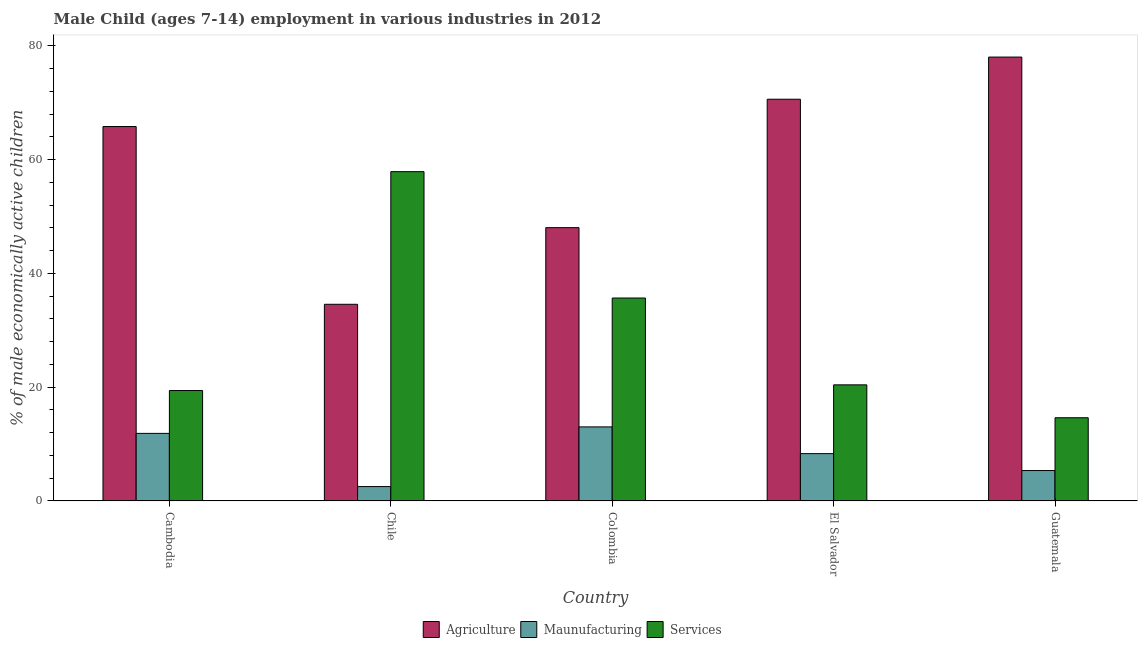How many different coloured bars are there?
Keep it short and to the point. 3. How many groups of bars are there?
Your answer should be very brief. 5. Are the number of bars per tick equal to the number of legend labels?
Ensure brevity in your answer.  Yes. Are the number of bars on each tick of the X-axis equal?
Provide a short and direct response. Yes. How many bars are there on the 5th tick from the right?
Make the answer very short. 3. What is the percentage of economically active children in agriculture in Colombia?
Offer a very short reply. 48.04. Across all countries, what is the maximum percentage of economically active children in agriculture?
Offer a very short reply. 78.02. Across all countries, what is the minimum percentage of economically active children in manufacturing?
Provide a short and direct response. 2.53. In which country was the percentage of economically active children in manufacturing maximum?
Your answer should be compact. Colombia. In which country was the percentage of economically active children in services minimum?
Your answer should be compact. Guatemala. What is the total percentage of economically active children in agriculture in the graph?
Offer a very short reply. 297.05. What is the difference between the percentage of economically active children in services in Chile and that in Colombia?
Your response must be concise. 22.21. What is the difference between the percentage of economically active children in services in Colombia and the percentage of economically active children in manufacturing in El Salvador?
Provide a short and direct response. 27.35. What is the average percentage of economically active children in services per country?
Offer a very short reply. 29.6. What is the difference between the percentage of economically active children in agriculture and percentage of economically active children in manufacturing in Cambodia?
Provide a short and direct response. 53.93. What is the ratio of the percentage of economically active children in agriculture in Cambodia to that in Colombia?
Give a very brief answer. 1.37. What is the difference between the highest and the second highest percentage of economically active children in manufacturing?
Give a very brief answer. 1.14. What is the difference between the highest and the lowest percentage of economically active children in manufacturing?
Provide a short and direct response. 10.49. In how many countries, is the percentage of economically active children in agriculture greater than the average percentage of economically active children in agriculture taken over all countries?
Your answer should be compact. 3. Is the sum of the percentage of economically active children in agriculture in Chile and Guatemala greater than the maximum percentage of economically active children in manufacturing across all countries?
Give a very brief answer. Yes. What does the 1st bar from the left in Guatemala represents?
Offer a terse response. Agriculture. What does the 2nd bar from the right in Guatemala represents?
Offer a terse response. Maunufacturing. Are all the bars in the graph horizontal?
Make the answer very short. No. Are the values on the major ticks of Y-axis written in scientific E-notation?
Give a very brief answer. No. Does the graph contain any zero values?
Keep it short and to the point. No. Where does the legend appear in the graph?
Your response must be concise. Bottom center. What is the title of the graph?
Give a very brief answer. Male Child (ages 7-14) employment in various industries in 2012. What is the label or title of the Y-axis?
Offer a very short reply. % of male economically active children. What is the % of male economically active children of Agriculture in Cambodia?
Provide a succinct answer. 65.81. What is the % of male economically active children in Maunufacturing in Cambodia?
Give a very brief answer. 11.88. What is the % of male economically active children of Services in Cambodia?
Your response must be concise. 19.41. What is the % of male economically active children in Agriculture in Chile?
Offer a terse response. 34.57. What is the % of male economically active children of Maunufacturing in Chile?
Provide a succinct answer. 2.53. What is the % of male economically active children in Services in Chile?
Offer a terse response. 57.88. What is the % of male economically active children of Agriculture in Colombia?
Keep it short and to the point. 48.04. What is the % of male economically active children in Maunufacturing in Colombia?
Ensure brevity in your answer.  13.02. What is the % of male economically active children of Services in Colombia?
Keep it short and to the point. 35.67. What is the % of male economically active children in Agriculture in El Salvador?
Provide a short and direct response. 70.61. What is the % of male economically active children in Maunufacturing in El Salvador?
Your answer should be compact. 8.32. What is the % of male economically active children in Services in El Salvador?
Offer a terse response. 20.41. What is the % of male economically active children of Agriculture in Guatemala?
Provide a short and direct response. 78.02. What is the % of male economically active children of Maunufacturing in Guatemala?
Offer a very short reply. 5.35. What is the % of male economically active children of Services in Guatemala?
Give a very brief answer. 14.63. Across all countries, what is the maximum % of male economically active children in Agriculture?
Give a very brief answer. 78.02. Across all countries, what is the maximum % of male economically active children in Maunufacturing?
Give a very brief answer. 13.02. Across all countries, what is the maximum % of male economically active children of Services?
Provide a short and direct response. 57.88. Across all countries, what is the minimum % of male economically active children in Agriculture?
Offer a very short reply. 34.57. Across all countries, what is the minimum % of male economically active children in Maunufacturing?
Your response must be concise. 2.53. Across all countries, what is the minimum % of male economically active children of Services?
Offer a terse response. 14.63. What is the total % of male economically active children of Agriculture in the graph?
Your answer should be very brief. 297.05. What is the total % of male economically active children in Maunufacturing in the graph?
Your answer should be compact. 41.1. What is the total % of male economically active children of Services in the graph?
Keep it short and to the point. 148. What is the difference between the % of male economically active children in Agriculture in Cambodia and that in Chile?
Provide a succinct answer. 31.24. What is the difference between the % of male economically active children of Maunufacturing in Cambodia and that in Chile?
Ensure brevity in your answer.  9.35. What is the difference between the % of male economically active children in Services in Cambodia and that in Chile?
Your answer should be compact. -38.47. What is the difference between the % of male economically active children in Agriculture in Cambodia and that in Colombia?
Your response must be concise. 17.77. What is the difference between the % of male economically active children in Maunufacturing in Cambodia and that in Colombia?
Provide a succinct answer. -1.14. What is the difference between the % of male economically active children in Services in Cambodia and that in Colombia?
Offer a very short reply. -16.26. What is the difference between the % of male economically active children of Maunufacturing in Cambodia and that in El Salvador?
Ensure brevity in your answer.  3.56. What is the difference between the % of male economically active children of Agriculture in Cambodia and that in Guatemala?
Your answer should be compact. -12.21. What is the difference between the % of male economically active children in Maunufacturing in Cambodia and that in Guatemala?
Provide a succinct answer. 6.53. What is the difference between the % of male economically active children of Services in Cambodia and that in Guatemala?
Provide a short and direct response. 4.78. What is the difference between the % of male economically active children of Agriculture in Chile and that in Colombia?
Keep it short and to the point. -13.47. What is the difference between the % of male economically active children of Maunufacturing in Chile and that in Colombia?
Provide a short and direct response. -10.49. What is the difference between the % of male economically active children in Services in Chile and that in Colombia?
Give a very brief answer. 22.21. What is the difference between the % of male economically active children in Agriculture in Chile and that in El Salvador?
Provide a succinct answer. -36.04. What is the difference between the % of male economically active children in Maunufacturing in Chile and that in El Salvador?
Your answer should be compact. -5.79. What is the difference between the % of male economically active children of Services in Chile and that in El Salvador?
Keep it short and to the point. 37.47. What is the difference between the % of male economically active children of Agriculture in Chile and that in Guatemala?
Your answer should be compact. -43.45. What is the difference between the % of male economically active children of Maunufacturing in Chile and that in Guatemala?
Your response must be concise. -2.82. What is the difference between the % of male economically active children of Services in Chile and that in Guatemala?
Give a very brief answer. 43.25. What is the difference between the % of male economically active children in Agriculture in Colombia and that in El Salvador?
Offer a terse response. -22.57. What is the difference between the % of male economically active children of Services in Colombia and that in El Salvador?
Your response must be concise. 15.26. What is the difference between the % of male economically active children of Agriculture in Colombia and that in Guatemala?
Give a very brief answer. -29.98. What is the difference between the % of male economically active children of Maunufacturing in Colombia and that in Guatemala?
Ensure brevity in your answer.  7.67. What is the difference between the % of male economically active children in Services in Colombia and that in Guatemala?
Ensure brevity in your answer.  21.04. What is the difference between the % of male economically active children in Agriculture in El Salvador and that in Guatemala?
Offer a terse response. -7.41. What is the difference between the % of male economically active children of Maunufacturing in El Salvador and that in Guatemala?
Offer a terse response. 2.97. What is the difference between the % of male economically active children in Services in El Salvador and that in Guatemala?
Keep it short and to the point. 5.78. What is the difference between the % of male economically active children of Agriculture in Cambodia and the % of male economically active children of Maunufacturing in Chile?
Provide a short and direct response. 63.28. What is the difference between the % of male economically active children of Agriculture in Cambodia and the % of male economically active children of Services in Chile?
Your response must be concise. 7.93. What is the difference between the % of male economically active children of Maunufacturing in Cambodia and the % of male economically active children of Services in Chile?
Offer a terse response. -46. What is the difference between the % of male economically active children of Agriculture in Cambodia and the % of male economically active children of Maunufacturing in Colombia?
Your answer should be very brief. 52.79. What is the difference between the % of male economically active children in Agriculture in Cambodia and the % of male economically active children in Services in Colombia?
Keep it short and to the point. 30.14. What is the difference between the % of male economically active children of Maunufacturing in Cambodia and the % of male economically active children of Services in Colombia?
Ensure brevity in your answer.  -23.79. What is the difference between the % of male economically active children in Agriculture in Cambodia and the % of male economically active children in Maunufacturing in El Salvador?
Your answer should be compact. 57.49. What is the difference between the % of male economically active children in Agriculture in Cambodia and the % of male economically active children in Services in El Salvador?
Keep it short and to the point. 45.4. What is the difference between the % of male economically active children in Maunufacturing in Cambodia and the % of male economically active children in Services in El Salvador?
Your answer should be very brief. -8.53. What is the difference between the % of male economically active children of Agriculture in Cambodia and the % of male economically active children of Maunufacturing in Guatemala?
Keep it short and to the point. 60.46. What is the difference between the % of male economically active children of Agriculture in Cambodia and the % of male economically active children of Services in Guatemala?
Make the answer very short. 51.18. What is the difference between the % of male economically active children of Maunufacturing in Cambodia and the % of male economically active children of Services in Guatemala?
Ensure brevity in your answer.  -2.75. What is the difference between the % of male economically active children in Agriculture in Chile and the % of male economically active children in Maunufacturing in Colombia?
Your answer should be very brief. 21.55. What is the difference between the % of male economically active children in Maunufacturing in Chile and the % of male economically active children in Services in Colombia?
Your response must be concise. -33.14. What is the difference between the % of male economically active children of Agriculture in Chile and the % of male economically active children of Maunufacturing in El Salvador?
Offer a very short reply. 26.25. What is the difference between the % of male economically active children of Agriculture in Chile and the % of male economically active children of Services in El Salvador?
Provide a succinct answer. 14.16. What is the difference between the % of male economically active children in Maunufacturing in Chile and the % of male economically active children in Services in El Salvador?
Give a very brief answer. -17.88. What is the difference between the % of male economically active children in Agriculture in Chile and the % of male economically active children in Maunufacturing in Guatemala?
Keep it short and to the point. 29.22. What is the difference between the % of male economically active children in Agriculture in Chile and the % of male economically active children in Services in Guatemala?
Keep it short and to the point. 19.94. What is the difference between the % of male economically active children in Maunufacturing in Chile and the % of male economically active children in Services in Guatemala?
Give a very brief answer. -12.1. What is the difference between the % of male economically active children in Agriculture in Colombia and the % of male economically active children in Maunufacturing in El Salvador?
Your answer should be very brief. 39.72. What is the difference between the % of male economically active children in Agriculture in Colombia and the % of male economically active children in Services in El Salvador?
Make the answer very short. 27.63. What is the difference between the % of male economically active children in Maunufacturing in Colombia and the % of male economically active children in Services in El Salvador?
Offer a very short reply. -7.39. What is the difference between the % of male economically active children in Agriculture in Colombia and the % of male economically active children in Maunufacturing in Guatemala?
Offer a terse response. 42.69. What is the difference between the % of male economically active children of Agriculture in Colombia and the % of male economically active children of Services in Guatemala?
Keep it short and to the point. 33.41. What is the difference between the % of male economically active children of Maunufacturing in Colombia and the % of male economically active children of Services in Guatemala?
Provide a succinct answer. -1.61. What is the difference between the % of male economically active children in Agriculture in El Salvador and the % of male economically active children in Maunufacturing in Guatemala?
Keep it short and to the point. 65.26. What is the difference between the % of male economically active children of Agriculture in El Salvador and the % of male economically active children of Services in Guatemala?
Your response must be concise. 55.98. What is the difference between the % of male economically active children in Maunufacturing in El Salvador and the % of male economically active children in Services in Guatemala?
Provide a short and direct response. -6.31. What is the average % of male economically active children in Agriculture per country?
Offer a very short reply. 59.41. What is the average % of male economically active children in Maunufacturing per country?
Ensure brevity in your answer.  8.22. What is the average % of male economically active children of Services per country?
Keep it short and to the point. 29.6. What is the difference between the % of male economically active children of Agriculture and % of male economically active children of Maunufacturing in Cambodia?
Ensure brevity in your answer.  53.93. What is the difference between the % of male economically active children in Agriculture and % of male economically active children in Services in Cambodia?
Provide a succinct answer. 46.4. What is the difference between the % of male economically active children in Maunufacturing and % of male economically active children in Services in Cambodia?
Keep it short and to the point. -7.53. What is the difference between the % of male economically active children of Agriculture and % of male economically active children of Maunufacturing in Chile?
Keep it short and to the point. 32.04. What is the difference between the % of male economically active children of Agriculture and % of male economically active children of Services in Chile?
Make the answer very short. -23.31. What is the difference between the % of male economically active children of Maunufacturing and % of male economically active children of Services in Chile?
Your response must be concise. -55.35. What is the difference between the % of male economically active children of Agriculture and % of male economically active children of Maunufacturing in Colombia?
Your answer should be compact. 35.02. What is the difference between the % of male economically active children of Agriculture and % of male economically active children of Services in Colombia?
Ensure brevity in your answer.  12.37. What is the difference between the % of male economically active children in Maunufacturing and % of male economically active children in Services in Colombia?
Provide a short and direct response. -22.65. What is the difference between the % of male economically active children in Agriculture and % of male economically active children in Maunufacturing in El Salvador?
Your answer should be very brief. 62.29. What is the difference between the % of male economically active children in Agriculture and % of male economically active children in Services in El Salvador?
Offer a terse response. 50.2. What is the difference between the % of male economically active children of Maunufacturing and % of male economically active children of Services in El Salvador?
Your answer should be compact. -12.09. What is the difference between the % of male economically active children in Agriculture and % of male economically active children in Maunufacturing in Guatemala?
Keep it short and to the point. 72.67. What is the difference between the % of male economically active children of Agriculture and % of male economically active children of Services in Guatemala?
Your answer should be compact. 63.39. What is the difference between the % of male economically active children in Maunufacturing and % of male economically active children in Services in Guatemala?
Your answer should be compact. -9.28. What is the ratio of the % of male economically active children of Agriculture in Cambodia to that in Chile?
Your response must be concise. 1.9. What is the ratio of the % of male economically active children of Maunufacturing in Cambodia to that in Chile?
Your answer should be compact. 4.7. What is the ratio of the % of male economically active children of Services in Cambodia to that in Chile?
Your answer should be compact. 0.34. What is the ratio of the % of male economically active children of Agriculture in Cambodia to that in Colombia?
Provide a succinct answer. 1.37. What is the ratio of the % of male economically active children of Maunufacturing in Cambodia to that in Colombia?
Give a very brief answer. 0.91. What is the ratio of the % of male economically active children in Services in Cambodia to that in Colombia?
Keep it short and to the point. 0.54. What is the ratio of the % of male economically active children of Agriculture in Cambodia to that in El Salvador?
Provide a short and direct response. 0.93. What is the ratio of the % of male economically active children of Maunufacturing in Cambodia to that in El Salvador?
Keep it short and to the point. 1.43. What is the ratio of the % of male economically active children in Services in Cambodia to that in El Salvador?
Make the answer very short. 0.95. What is the ratio of the % of male economically active children in Agriculture in Cambodia to that in Guatemala?
Provide a succinct answer. 0.84. What is the ratio of the % of male economically active children of Maunufacturing in Cambodia to that in Guatemala?
Give a very brief answer. 2.22. What is the ratio of the % of male economically active children of Services in Cambodia to that in Guatemala?
Give a very brief answer. 1.33. What is the ratio of the % of male economically active children in Agriculture in Chile to that in Colombia?
Provide a short and direct response. 0.72. What is the ratio of the % of male economically active children in Maunufacturing in Chile to that in Colombia?
Your response must be concise. 0.19. What is the ratio of the % of male economically active children in Services in Chile to that in Colombia?
Give a very brief answer. 1.62. What is the ratio of the % of male economically active children of Agriculture in Chile to that in El Salvador?
Give a very brief answer. 0.49. What is the ratio of the % of male economically active children in Maunufacturing in Chile to that in El Salvador?
Keep it short and to the point. 0.3. What is the ratio of the % of male economically active children in Services in Chile to that in El Salvador?
Ensure brevity in your answer.  2.84. What is the ratio of the % of male economically active children of Agriculture in Chile to that in Guatemala?
Give a very brief answer. 0.44. What is the ratio of the % of male economically active children in Maunufacturing in Chile to that in Guatemala?
Your answer should be compact. 0.47. What is the ratio of the % of male economically active children in Services in Chile to that in Guatemala?
Your answer should be compact. 3.96. What is the ratio of the % of male economically active children in Agriculture in Colombia to that in El Salvador?
Keep it short and to the point. 0.68. What is the ratio of the % of male economically active children in Maunufacturing in Colombia to that in El Salvador?
Offer a terse response. 1.56. What is the ratio of the % of male economically active children of Services in Colombia to that in El Salvador?
Provide a succinct answer. 1.75. What is the ratio of the % of male economically active children of Agriculture in Colombia to that in Guatemala?
Offer a very short reply. 0.62. What is the ratio of the % of male economically active children of Maunufacturing in Colombia to that in Guatemala?
Ensure brevity in your answer.  2.43. What is the ratio of the % of male economically active children in Services in Colombia to that in Guatemala?
Your answer should be very brief. 2.44. What is the ratio of the % of male economically active children of Agriculture in El Salvador to that in Guatemala?
Provide a short and direct response. 0.91. What is the ratio of the % of male economically active children of Maunufacturing in El Salvador to that in Guatemala?
Provide a succinct answer. 1.56. What is the ratio of the % of male economically active children of Services in El Salvador to that in Guatemala?
Offer a terse response. 1.4. What is the difference between the highest and the second highest % of male economically active children of Agriculture?
Make the answer very short. 7.41. What is the difference between the highest and the second highest % of male economically active children of Maunufacturing?
Your answer should be compact. 1.14. What is the difference between the highest and the second highest % of male economically active children of Services?
Keep it short and to the point. 22.21. What is the difference between the highest and the lowest % of male economically active children of Agriculture?
Your answer should be compact. 43.45. What is the difference between the highest and the lowest % of male economically active children in Maunufacturing?
Provide a short and direct response. 10.49. What is the difference between the highest and the lowest % of male economically active children of Services?
Your answer should be very brief. 43.25. 